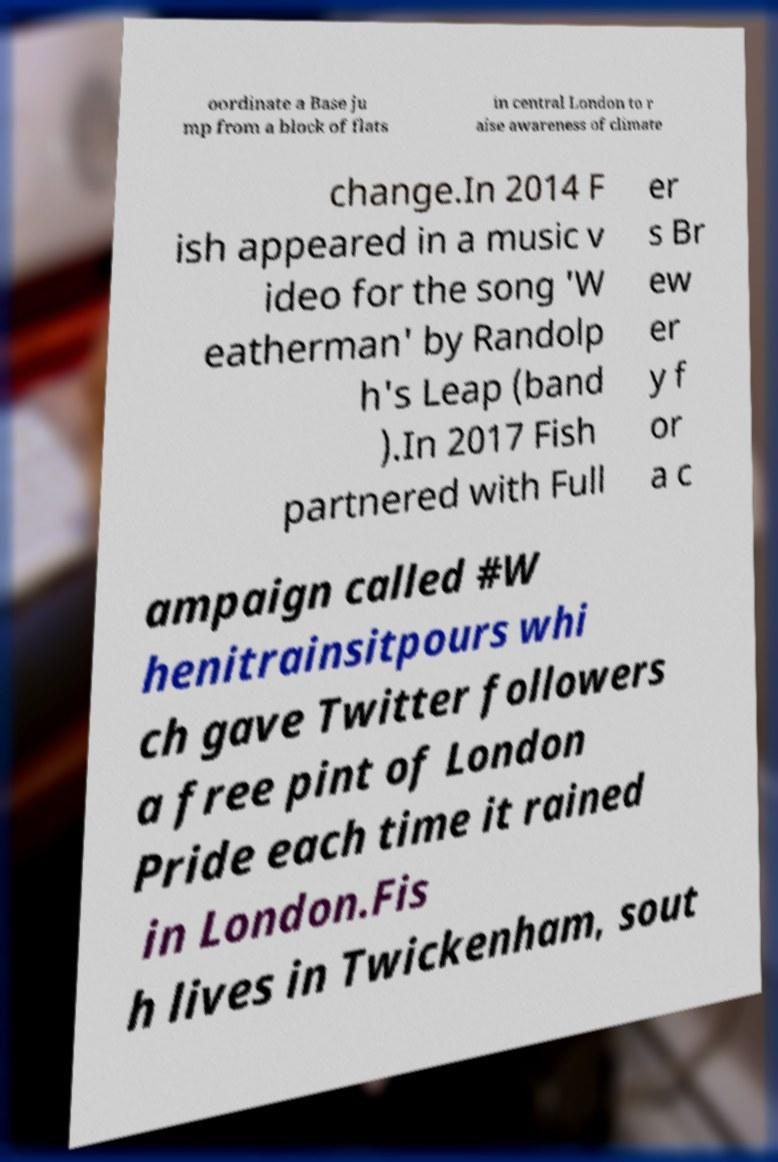What messages or text are displayed in this image? I need them in a readable, typed format. oordinate a Base ju mp from a block of flats in central London to r aise awareness of climate change.In 2014 F ish appeared in a music v ideo for the song 'W eatherman' by Randolp h's Leap (band ).In 2017 Fish partnered with Full er s Br ew er y f or a c ampaign called #W henitrainsitpours whi ch gave Twitter followers a free pint of London Pride each time it rained in London.Fis h lives in Twickenham, sout 